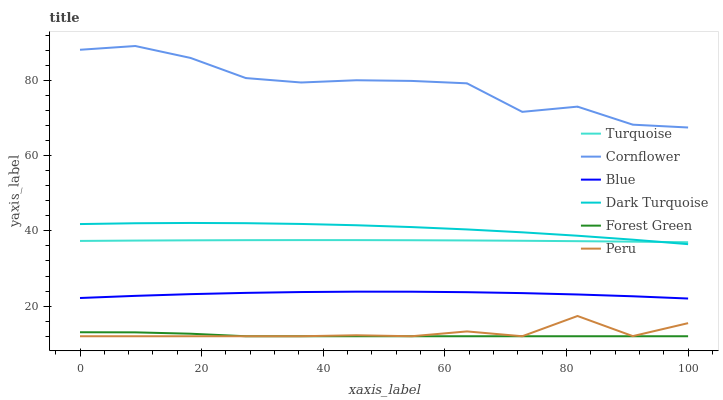Does Forest Green have the minimum area under the curve?
Answer yes or no. Yes. Does Cornflower have the maximum area under the curve?
Answer yes or no. Yes. Does Turquoise have the minimum area under the curve?
Answer yes or no. No. Does Turquoise have the maximum area under the curve?
Answer yes or no. No. Is Turquoise the smoothest?
Answer yes or no. Yes. Is Cornflower the roughest?
Answer yes or no. Yes. Is Cornflower the smoothest?
Answer yes or no. No. Is Turquoise the roughest?
Answer yes or no. No. Does Forest Green have the lowest value?
Answer yes or no. Yes. Does Turquoise have the lowest value?
Answer yes or no. No. Does Cornflower have the highest value?
Answer yes or no. Yes. Does Turquoise have the highest value?
Answer yes or no. No. Is Blue less than Cornflower?
Answer yes or no. Yes. Is Cornflower greater than Dark Turquoise?
Answer yes or no. Yes. Does Peru intersect Forest Green?
Answer yes or no. Yes. Is Peru less than Forest Green?
Answer yes or no. No. Is Peru greater than Forest Green?
Answer yes or no. No. Does Blue intersect Cornflower?
Answer yes or no. No. 